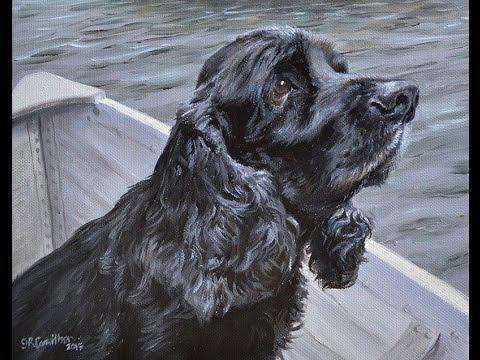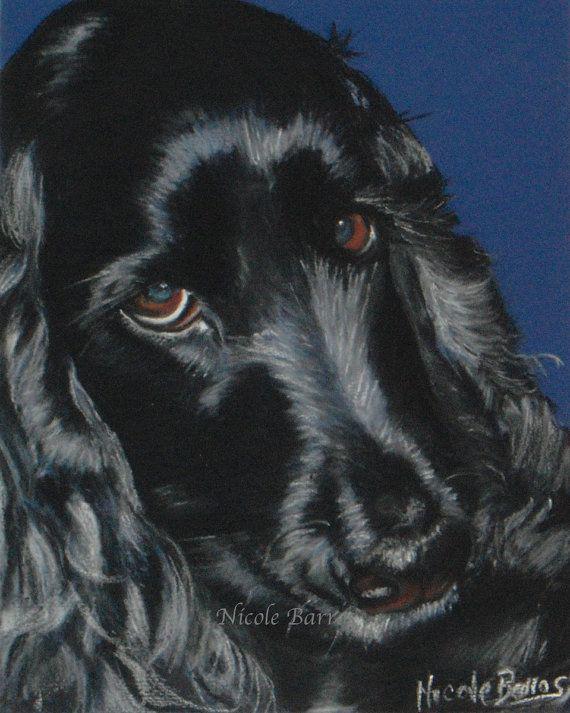The first image is the image on the left, the second image is the image on the right. Assess this claim about the two images: "All images show only dogs with black fur on their faces.". Correct or not? Answer yes or no. Yes. The first image is the image on the left, the second image is the image on the right. Given the left and right images, does the statement "All of the dogs are black." hold true? Answer yes or no. Yes. 